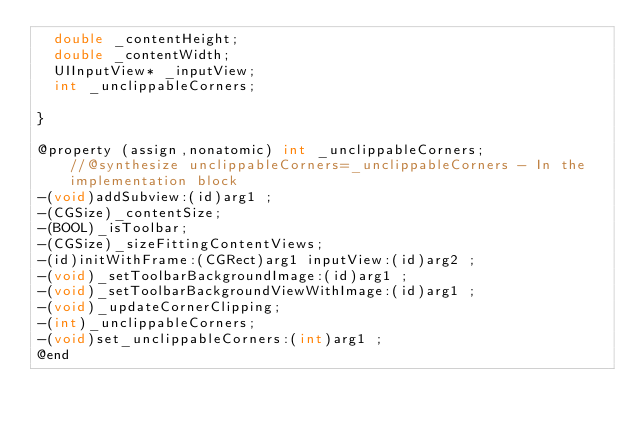<code> <loc_0><loc_0><loc_500><loc_500><_C_>	double _contentHeight;
	double _contentWidth;
	UIInputView* _inputView;
	int _unclippableCorners;

}

@property (assign,nonatomic) int _unclippableCorners;              //@synthesize unclippableCorners=_unclippableCorners - In the implementation block
-(void)addSubview:(id)arg1 ;
-(CGSize)_contentSize;
-(BOOL)_isToolbar;
-(CGSize)_sizeFittingContentViews;
-(id)initWithFrame:(CGRect)arg1 inputView:(id)arg2 ;
-(void)_setToolbarBackgroundImage:(id)arg1 ;
-(void)_setToolbarBackgroundViewWithImage:(id)arg1 ;
-(void)_updateCornerClipping;
-(int)_unclippableCorners;
-(void)set_unclippableCorners:(int)arg1 ;
@end

</code> 